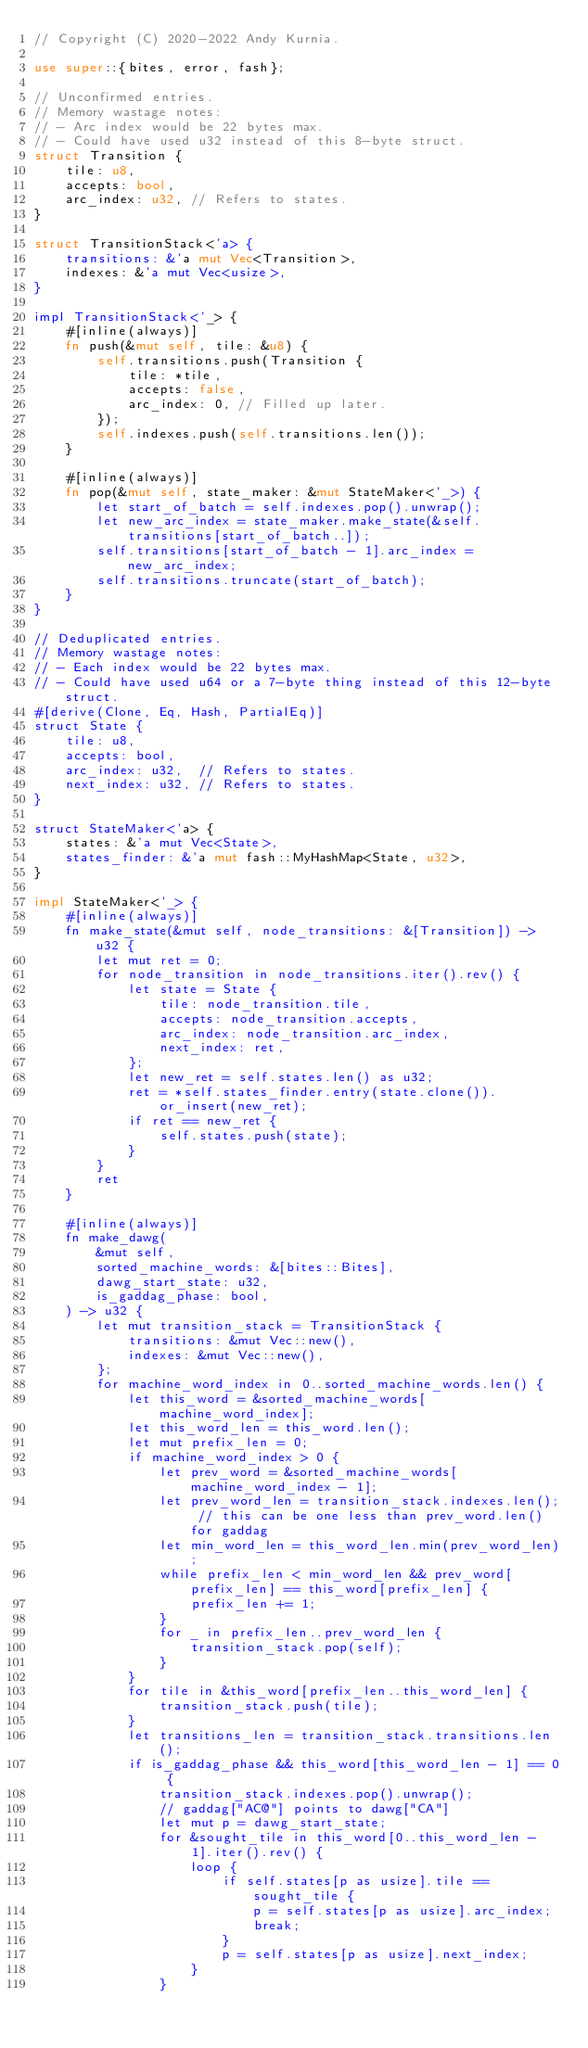<code> <loc_0><loc_0><loc_500><loc_500><_Rust_>// Copyright (C) 2020-2022 Andy Kurnia.

use super::{bites, error, fash};

// Unconfirmed entries.
// Memory wastage notes:
// - Arc index would be 22 bytes max.
// - Could have used u32 instead of this 8-byte struct.
struct Transition {
    tile: u8,
    accepts: bool,
    arc_index: u32, // Refers to states.
}

struct TransitionStack<'a> {
    transitions: &'a mut Vec<Transition>,
    indexes: &'a mut Vec<usize>,
}

impl TransitionStack<'_> {
    #[inline(always)]
    fn push(&mut self, tile: &u8) {
        self.transitions.push(Transition {
            tile: *tile,
            accepts: false,
            arc_index: 0, // Filled up later.
        });
        self.indexes.push(self.transitions.len());
    }

    #[inline(always)]
    fn pop(&mut self, state_maker: &mut StateMaker<'_>) {
        let start_of_batch = self.indexes.pop().unwrap();
        let new_arc_index = state_maker.make_state(&self.transitions[start_of_batch..]);
        self.transitions[start_of_batch - 1].arc_index = new_arc_index;
        self.transitions.truncate(start_of_batch);
    }
}

// Deduplicated entries.
// Memory wastage notes:
// - Each index would be 22 bytes max.
// - Could have used u64 or a 7-byte thing instead of this 12-byte struct.
#[derive(Clone, Eq, Hash, PartialEq)]
struct State {
    tile: u8,
    accepts: bool,
    arc_index: u32,  // Refers to states.
    next_index: u32, // Refers to states.
}

struct StateMaker<'a> {
    states: &'a mut Vec<State>,
    states_finder: &'a mut fash::MyHashMap<State, u32>,
}

impl StateMaker<'_> {
    #[inline(always)]
    fn make_state(&mut self, node_transitions: &[Transition]) -> u32 {
        let mut ret = 0;
        for node_transition in node_transitions.iter().rev() {
            let state = State {
                tile: node_transition.tile,
                accepts: node_transition.accepts,
                arc_index: node_transition.arc_index,
                next_index: ret,
            };
            let new_ret = self.states.len() as u32;
            ret = *self.states_finder.entry(state.clone()).or_insert(new_ret);
            if ret == new_ret {
                self.states.push(state);
            }
        }
        ret
    }

    #[inline(always)]
    fn make_dawg(
        &mut self,
        sorted_machine_words: &[bites::Bites],
        dawg_start_state: u32,
        is_gaddag_phase: bool,
    ) -> u32 {
        let mut transition_stack = TransitionStack {
            transitions: &mut Vec::new(),
            indexes: &mut Vec::new(),
        };
        for machine_word_index in 0..sorted_machine_words.len() {
            let this_word = &sorted_machine_words[machine_word_index];
            let this_word_len = this_word.len();
            let mut prefix_len = 0;
            if machine_word_index > 0 {
                let prev_word = &sorted_machine_words[machine_word_index - 1];
                let prev_word_len = transition_stack.indexes.len(); // this can be one less than prev_word.len() for gaddag
                let min_word_len = this_word_len.min(prev_word_len);
                while prefix_len < min_word_len && prev_word[prefix_len] == this_word[prefix_len] {
                    prefix_len += 1;
                }
                for _ in prefix_len..prev_word_len {
                    transition_stack.pop(self);
                }
            }
            for tile in &this_word[prefix_len..this_word_len] {
                transition_stack.push(tile);
            }
            let transitions_len = transition_stack.transitions.len();
            if is_gaddag_phase && this_word[this_word_len - 1] == 0 {
                transition_stack.indexes.pop().unwrap();
                // gaddag["AC@"] points to dawg["CA"]
                let mut p = dawg_start_state;
                for &sought_tile in this_word[0..this_word_len - 1].iter().rev() {
                    loop {
                        if self.states[p as usize].tile == sought_tile {
                            p = self.states[p as usize].arc_index;
                            break;
                        }
                        p = self.states[p as usize].next_index;
                    }
                }</code> 